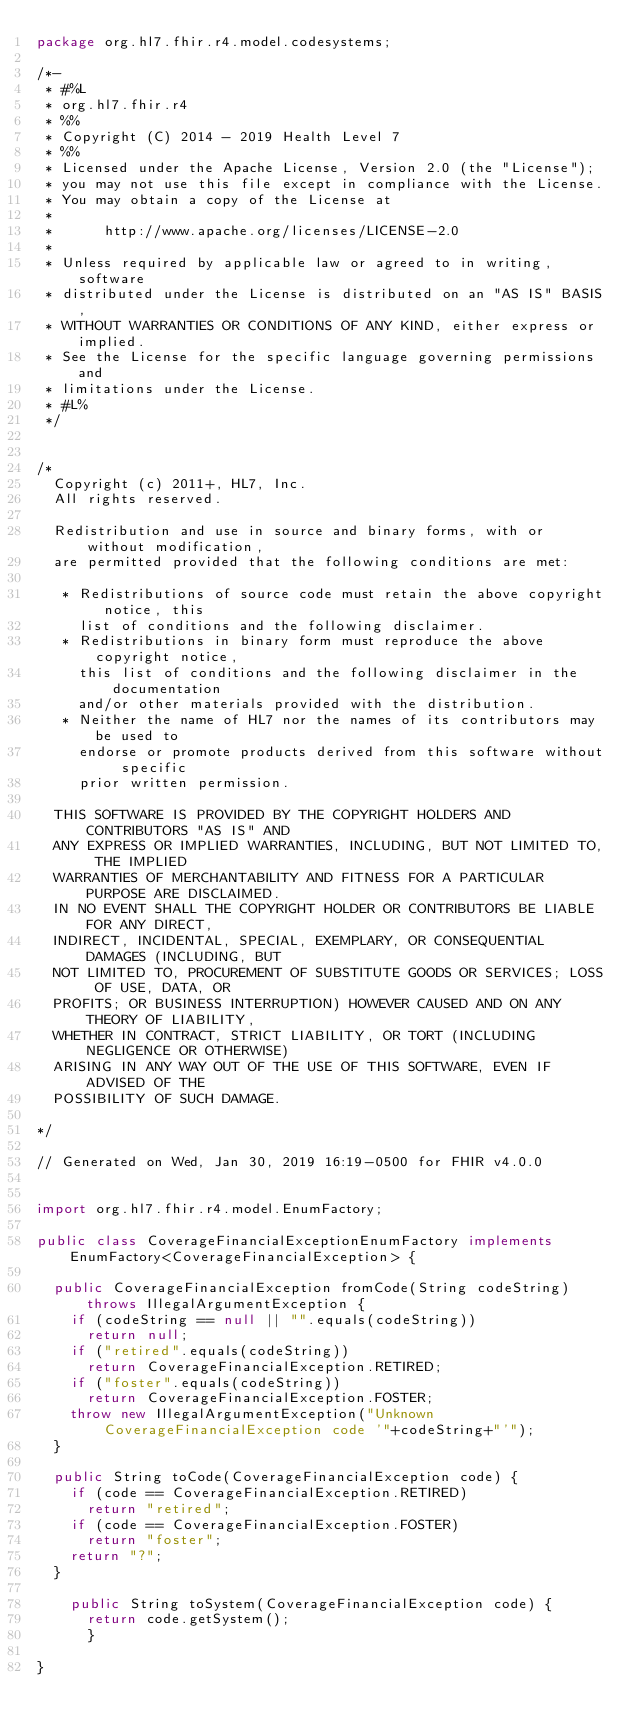<code> <loc_0><loc_0><loc_500><loc_500><_Java_>package org.hl7.fhir.r4.model.codesystems;

/*-
 * #%L
 * org.hl7.fhir.r4
 * %%
 * Copyright (C) 2014 - 2019 Health Level 7
 * %%
 * Licensed under the Apache License, Version 2.0 (the "License");
 * you may not use this file except in compliance with the License.
 * You may obtain a copy of the License at
 * 
 *      http://www.apache.org/licenses/LICENSE-2.0
 * 
 * Unless required by applicable law or agreed to in writing, software
 * distributed under the License is distributed on an "AS IS" BASIS,
 * WITHOUT WARRANTIES OR CONDITIONS OF ANY KIND, either express or implied.
 * See the License for the specific language governing permissions and
 * limitations under the License.
 * #L%
 */


/*
  Copyright (c) 2011+, HL7, Inc.
  All rights reserved.
  
  Redistribution and use in source and binary forms, with or without modification, 
  are permitted provided that the following conditions are met:
  
   * Redistributions of source code must retain the above copyright notice, this 
     list of conditions and the following disclaimer.
   * Redistributions in binary form must reproduce the above copyright notice, 
     this list of conditions and the following disclaimer in the documentation 
     and/or other materials provided with the distribution.
   * Neither the name of HL7 nor the names of its contributors may be used to 
     endorse or promote products derived from this software without specific 
     prior written permission.
  
  THIS SOFTWARE IS PROVIDED BY THE COPYRIGHT HOLDERS AND CONTRIBUTORS "AS IS" AND 
  ANY EXPRESS OR IMPLIED WARRANTIES, INCLUDING, BUT NOT LIMITED TO, THE IMPLIED 
  WARRANTIES OF MERCHANTABILITY AND FITNESS FOR A PARTICULAR PURPOSE ARE DISCLAIMED. 
  IN NO EVENT SHALL THE COPYRIGHT HOLDER OR CONTRIBUTORS BE LIABLE FOR ANY DIRECT, 
  INDIRECT, INCIDENTAL, SPECIAL, EXEMPLARY, OR CONSEQUENTIAL DAMAGES (INCLUDING, BUT 
  NOT LIMITED TO, PROCUREMENT OF SUBSTITUTE GOODS OR SERVICES; LOSS OF USE, DATA, OR 
  PROFITS; OR BUSINESS INTERRUPTION) HOWEVER CAUSED AND ON ANY THEORY OF LIABILITY, 
  WHETHER IN CONTRACT, STRICT LIABILITY, OR TORT (INCLUDING NEGLIGENCE OR OTHERWISE) 
  ARISING IN ANY WAY OUT OF THE USE OF THIS SOFTWARE, EVEN IF ADVISED OF THE 
  POSSIBILITY OF SUCH DAMAGE.
  
*/

// Generated on Wed, Jan 30, 2019 16:19-0500 for FHIR v4.0.0


import org.hl7.fhir.r4.model.EnumFactory;

public class CoverageFinancialExceptionEnumFactory implements EnumFactory<CoverageFinancialException> {

  public CoverageFinancialException fromCode(String codeString) throws IllegalArgumentException {
    if (codeString == null || "".equals(codeString))
      return null;
    if ("retired".equals(codeString))
      return CoverageFinancialException.RETIRED;
    if ("foster".equals(codeString))
      return CoverageFinancialException.FOSTER;
    throw new IllegalArgumentException("Unknown CoverageFinancialException code '"+codeString+"'");
  }

  public String toCode(CoverageFinancialException code) {
    if (code == CoverageFinancialException.RETIRED)
      return "retired";
    if (code == CoverageFinancialException.FOSTER)
      return "foster";
    return "?";
  }

    public String toSystem(CoverageFinancialException code) {
      return code.getSystem();
      }

}

</code> 